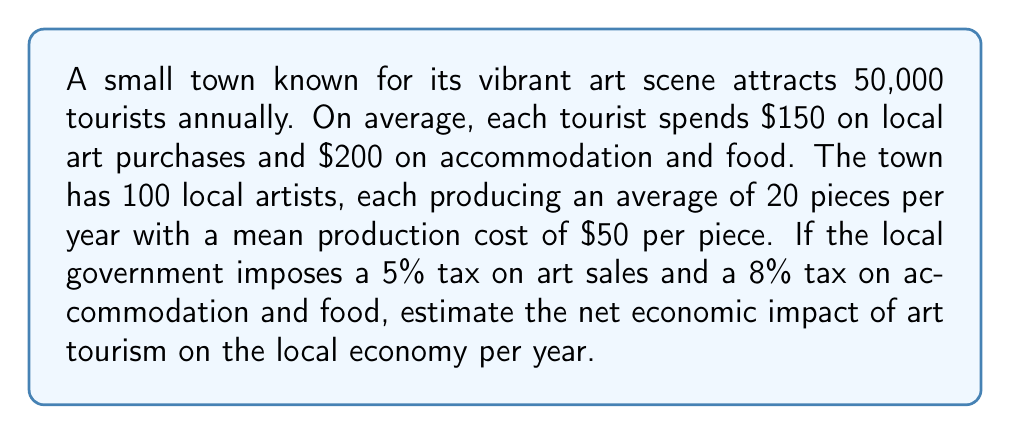Could you help me with this problem? Let's break this problem down step by step:

1. Calculate total tourist spending on art:
   $$ \text{Art spending} = 50,000 \times \$150 = \$7,500,000 $$

2. Calculate total tourist spending on accommodation and food:
   $$ \text{Accommodation and food spending} = 50,000 \times \$200 = \$10,000,000 $$

3. Calculate total tourist spending:
   $$ \text{Total spending} = \$7,500,000 + \$10,000,000 = \$17,500,000 $$

4. Calculate tax revenue from art sales:
   $$ \text{Art tax revenue} = \$7,500,000 \times 5\% = \$375,000 $$

5. Calculate tax revenue from accommodation and food:
   $$ \text{Accommodation and food tax revenue} = \$10,000,000 \times 8\% = \$800,000 $$

6. Calculate total tax revenue:
   $$ \text{Total tax revenue} = \$375,000 + \$800,000 = \$1,175,000 $$

7. Calculate the production cost for local artists:
   $$ \text{Production cost} = 100 \text{ artists} \times 20 \text{ pieces} \times \$50 = \$100,000 $$

8. Calculate the net economic impact:
   $$ \text{Net impact} = \text{Total spending} + \text{Total tax revenue} - \text{Production cost} $$
   $$ \text{Net impact} = \$17,500,000 + \$1,175,000 - \$100,000 = \$18,575,000 $$
Answer: The net economic impact of art tourism on the local economy per year is $18,575,000. 